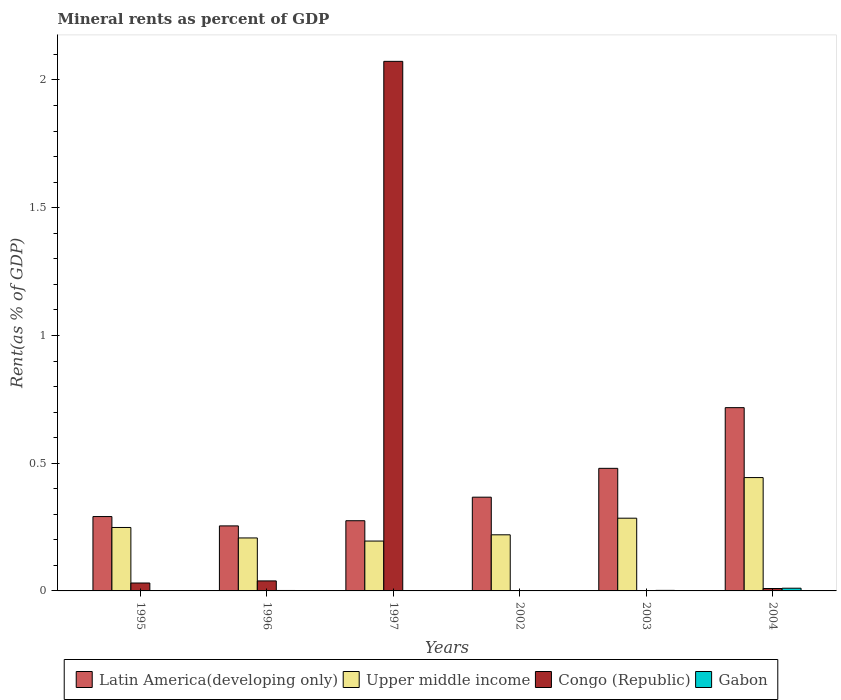How many bars are there on the 6th tick from the left?
Your answer should be very brief. 4. What is the label of the 5th group of bars from the left?
Give a very brief answer. 2003. What is the mineral rent in Congo (Republic) in 2002?
Make the answer very short. 0. Across all years, what is the maximum mineral rent in Latin America(developing only)?
Your response must be concise. 0.72. Across all years, what is the minimum mineral rent in Latin America(developing only)?
Give a very brief answer. 0.25. In which year was the mineral rent in Congo (Republic) maximum?
Your answer should be very brief. 1997. What is the total mineral rent in Congo (Republic) in the graph?
Provide a short and direct response. 2.15. What is the difference between the mineral rent in Gabon in 1995 and that in 1996?
Ensure brevity in your answer.  -0. What is the difference between the mineral rent in Latin America(developing only) in 1996 and the mineral rent in Gabon in 2004?
Offer a terse response. 0.24. What is the average mineral rent in Latin America(developing only) per year?
Provide a succinct answer. 0.4. In the year 1995, what is the difference between the mineral rent in Congo (Republic) and mineral rent in Latin America(developing only)?
Give a very brief answer. -0.26. What is the ratio of the mineral rent in Gabon in 2003 to that in 2004?
Provide a short and direct response. 0.2. Is the mineral rent in Upper middle income in 1997 less than that in 2002?
Provide a succinct answer. Yes. Is the difference between the mineral rent in Congo (Republic) in 1995 and 2004 greater than the difference between the mineral rent in Latin America(developing only) in 1995 and 2004?
Make the answer very short. Yes. What is the difference between the highest and the second highest mineral rent in Congo (Republic)?
Your response must be concise. 2.03. What is the difference between the highest and the lowest mineral rent in Latin America(developing only)?
Ensure brevity in your answer.  0.46. Is the sum of the mineral rent in Upper middle income in 1996 and 2003 greater than the maximum mineral rent in Latin America(developing only) across all years?
Offer a very short reply. No. What does the 4th bar from the left in 2004 represents?
Keep it short and to the point. Gabon. What does the 4th bar from the right in 1995 represents?
Make the answer very short. Latin America(developing only). Are all the bars in the graph horizontal?
Give a very brief answer. No. Are the values on the major ticks of Y-axis written in scientific E-notation?
Offer a terse response. No. Does the graph contain any zero values?
Make the answer very short. No. Does the graph contain grids?
Offer a very short reply. No. Where does the legend appear in the graph?
Give a very brief answer. Bottom center. How many legend labels are there?
Your answer should be very brief. 4. What is the title of the graph?
Offer a terse response. Mineral rents as percent of GDP. Does "Fiji" appear as one of the legend labels in the graph?
Your answer should be very brief. No. What is the label or title of the Y-axis?
Your answer should be very brief. Rent(as % of GDP). What is the Rent(as % of GDP) in Latin America(developing only) in 1995?
Keep it short and to the point. 0.29. What is the Rent(as % of GDP) in Upper middle income in 1995?
Keep it short and to the point. 0.25. What is the Rent(as % of GDP) in Congo (Republic) in 1995?
Give a very brief answer. 0.03. What is the Rent(as % of GDP) of Gabon in 1995?
Give a very brief answer. 0. What is the Rent(as % of GDP) of Latin America(developing only) in 1996?
Provide a short and direct response. 0.25. What is the Rent(as % of GDP) of Upper middle income in 1996?
Your answer should be very brief. 0.21. What is the Rent(as % of GDP) of Congo (Republic) in 1996?
Your response must be concise. 0.04. What is the Rent(as % of GDP) in Gabon in 1996?
Give a very brief answer. 0. What is the Rent(as % of GDP) in Latin America(developing only) in 1997?
Ensure brevity in your answer.  0.27. What is the Rent(as % of GDP) in Upper middle income in 1997?
Your answer should be compact. 0.2. What is the Rent(as % of GDP) of Congo (Republic) in 1997?
Offer a terse response. 2.07. What is the Rent(as % of GDP) in Gabon in 1997?
Ensure brevity in your answer.  0. What is the Rent(as % of GDP) in Latin America(developing only) in 2002?
Offer a terse response. 0.37. What is the Rent(as % of GDP) of Upper middle income in 2002?
Your answer should be compact. 0.22. What is the Rent(as % of GDP) in Congo (Republic) in 2002?
Keep it short and to the point. 0. What is the Rent(as % of GDP) of Gabon in 2002?
Offer a terse response. 0. What is the Rent(as % of GDP) of Latin America(developing only) in 2003?
Your response must be concise. 0.48. What is the Rent(as % of GDP) in Upper middle income in 2003?
Your answer should be compact. 0.28. What is the Rent(as % of GDP) in Congo (Republic) in 2003?
Your response must be concise. 0. What is the Rent(as % of GDP) in Gabon in 2003?
Keep it short and to the point. 0. What is the Rent(as % of GDP) in Latin America(developing only) in 2004?
Your response must be concise. 0.72. What is the Rent(as % of GDP) in Upper middle income in 2004?
Offer a very short reply. 0.44. What is the Rent(as % of GDP) of Congo (Republic) in 2004?
Provide a short and direct response. 0.01. What is the Rent(as % of GDP) of Gabon in 2004?
Your answer should be compact. 0.01. Across all years, what is the maximum Rent(as % of GDP) of Latin America(developing only)?
Provide a short and direct response. 0.72. Across all years, what is the maximum Rent(as % of GDP) of Upper middle income?
Give a very brief answer. 0.44. Across all years, what is the maximum Rent(as % of GDP) of Congo (Republic)?
Your response must be concise. 2.07. Across all years, what is the maximum Rent(as % of GDP) of Gabon?
Make the answer very short. 0.01. Across all years, what is the minimum Rent(as % of GDP) of Latin America(developing only)?
Your answer should be very brief. 0.25. Across all years, what is the minimum Rent(as % of GDP) in Upper middle income?
Provide a succinct answer. 0.2. Across all years, what is the minimum Rent(as % of GDP) of Congo (Republic)?
Your response must be concise. 0. Across all years, what is the minimum Rent(as % of GDP) of Gabon?
Provide a short and direct response. 0. What is the total Rent(as % of GDP) in Latin America(developing only) in the graph?
Your answer should be very brief. 2.38. What is the total Rent(as % of GDP) of Upper middle income in the graph?
Give a very brief answer. 1.6. What is the total Rent(as % of GDP) in Congo (Republic) in the graph?
Keep it short and to the point. 2.15. What is the total Rent(as % of GDP) of Gabon in the graph?
Make the answer very short. 0.02. What is the difference between the Rent(as % of GDP) of Latin America(developing only) in 1995 and that in 1996?
Offer a terse response. 0.04. What is the difference between the Rent(as % of GDP) of Upper middle income in 1995 and that in 1996?
Provide a short and direct response. 0.04. What is the difference between the Rent(as % of GDP) of Congo (Republic) in 1995 and that in 1996?
Give a very brief answer. -0.01. What is the difference between the Rent(as % of GDP) of Gabon in 1995 and that in 1996?
Ensure brevity in your answer.  -0. What is the difference between the Rent(as % of GDP) in Latin America(developing only) in 1995 and that in 1997?
Offer a terse response. 0.02. What is the difference between the Rent(as % of GDP) of Upper middle income in 1995 and that in 1997?
Your answer should be compact. 0.05. What is the difference between the Rent(as % of GDP) of Congo (Republic) in 1995 and that in 1997?
Provide a short and direct response. -2.04. What is the difference between the Rent(as % of GDP) of Gabon in 1995 and that in 1997?
Provide a short and direct response. 0. What is the difference between the Rent(as % of GDP) of Latin America(developing only) in 1995 and that in 2002?
Ensure brevity in your answer.  -0.08. What is the difference between the Rent(as % of GDP) of Upper middle income in 1995 and that in 2002?
Your answer should be very brief. 0.03. What is the difference between the Rent(as % of GDP) in Congo (Republic) in 1995 and that in 2002?
Give a very brief answer. 0.03. What is the difference between the Rent(as % of GDP) in Gabon in 1995 and that in 2002?
Provide a short and direct response. 0. What is the difference between the Rent(as % of GDP) in Latin America(developing only) in 1995 and that in 2003?
Provide a short and direct response. -0.19. What is the difference between the Rent(as % of GDP) in Upper middle income in 1995 and that in 2003?
Provide a short and direct response. -0.04. What is the difference between the Rent(as % of GDP) in Congo (Republic) in 1995 and that in 2003?
Your response must be concise. 0.03. What is the difference between the Rent(as % of GDP) of Gabon in 1995 and that in 2003?
Offer a terse response. -0. What is the difference between the Rent(as % of GDP) in Latin America(developing only) in 1995 and that in 2004?
Offer a terse response. -0.43. What is the difference between the Rent(as % of GDP) of Upper middle income in 1995 and that in 2004?
Give a very brief answer. -0.2. What is the difference between the Rent(as % of GDP) in Congo (Republic) in 1995 and that in 2004?
Your answer should be very brief. 0.02. What is the difference between the Rent(as % of GDP) of Gabon in 1995 and that in 2004?
Provide a short and direct response. -0.01. What is the difference between the Rent(as % of GDP) in Latin America(developing only) in 1996 and that in 1997?
Provide a short and direct response. -0.02. What is the difference between the Rent(as % of GDP) of Upper middle income in 1996 and that in 1997?
Give a very brief answer. 0.01. What is the difference between the Rent(as % of GDP) in Congo (Republic) in 1996 and that in 1997?
Your answer should be compact. -2.03. What is the difference between the Rent(as % of GDP) of Gabon in 1996 and that in 1997?
Your response must be concise. 0. What is the difference between the Rent(as % of GDP) of Latin America(developing only) in 1996 and that in 2002?
Keep it short and to the point. -0.11. What is the difference between the Rent(as % of GDP) of Upper middle income in 1996 and that in 2002?
Offer a terse response. -0.01. What is the difference between the Rent(as % of GDP) in Congo (Republic) in 1996 and that in 2002?
Offer a terse response. 0.04. What is the difference between the Rent(as % of GDP) in Gabon in 1996 and that in 2002?
Provide a succinct answer. 0. What is the difference between the Rent(as % of GDP) of Latin America(developing only) in 1996 and that in 2003?
Make the answer very short. -0.23. What is the difference between the Rent(as % of GDP) in Upper middle income in 1996 and that in 2003?
Make the answer very short. -0.08. What is the difference between the Rent(as % of GDP) of Congo (Republic) in 1996 and that in 2003?
Make the answer very short. 0.04. What is the difference between the Rent(as % of GDP) of Gabon in 1996 and that in 2003?
Offer a terse response. -0. What is the difference between the Rent(as % of GDP) of Latin America(developing only) in 1996 and that in 2004?
Your answer should be very brief. -0.46. What is the difference between the Rent(as % of GDP) of Upper middle income in 1996 and that in 2004?
Offer a terse response. -0.24. What is the difference between the Rent(as % of GDP) of Congo (Republic) in 1996 and that in 2004?
Your answer should be compact. 0.03. What is the difference between the Rent(as % of GDP) of Gabon in 1996 and that in 2004?
Give a very brief answer. -0.01. What is the difference between the Rent(as % of GDP) in Latin America(developing only) in 1997 and that in 2002?
Ensure brevity in your answer.  -0.09. What is the difference between the Rent(as % of GDP) of Upper middle income in 1997 and that in 2002?
Your response must be concise. -0.02. What is the difference between the Rent(as % of GDP) of Congo (Republic) in 1997 and that in 2002?
Offer a terse response. 2.07. What is the difference between the Rent(as % of GDP) in Gabon in 1997 and that in 2002?
Keep it short and to the point. -0. What is the difference between the Rent(as % of GDP) in Latin America(developing only) in 1997 and that in 2003?
Your answer should be compact. -0.2. What is the difference between the Rent(as % of GDP) in Upper middle income in 1997 and that in 2003?
Offer a terse response. -0.09. What is the difference between the Rent(as % of GDP) in Congo (Republic) in 1997 and that in 2003?
Your response must be concise. 2.07. What is the difference between the Rent(as % of GDP) in Gabon in 1997 and that in 2003?
Give a very brief answer. -0. What is the difference between the Rent(as % of GDP) in Latin America(developing only) in 1997 and that in 2004?
Provide a short and direct response. -0.44. What is the difference between the Rent(as % of GDP) of Upper middle income in 1997 and that in 2004?
Keep it short and to the point. -0.25. What is the difference between the Rent(as % of GDP) in Congo (Republic) in 1997 and that in 2004?
Provide a succinct answer. 2.06. What is the difference between the Rent(as % of GDP) in Gabon in 1997 and that in 2004?
Offer a very short reply. -0.01. What is the difference between the Rent(as % of GDP) of Latin America(developing only) in 2002 and that in 2003?
Your response must be concise. -0.11. What is the difference between the Rent(as % of GDP) of Upper middle income in 2002 and that in 2003?
Your answer should be very brief. -0.07. What is the difference between the Rent(as % of GDP) in Congo (Republic) in 2002 and that in 2003?
Offer a very short reply. -0. What is the difference between the Rent(as % of GDP) of Gabon in 2002 and that in 2003?
Give a very brief answer. -0. What is the difference between the Rent(as % of GDP) in Latin America(developing only) in 2002 and that in 2004?
Your response must be concise. -0.35. What is the difference between the Rent(as % of GDP) of Upper middle income in 2002 and that in 2004?
Your response must be concise. -0.22. What is the difference between the Rent(as % of GDP) in Congo (Republic) in 2002 and that in 2004?
Keep it short and to the point. -0.01. What is the difference between the Rent(as % of GDP) in Gabon in 2002 and that in 2004?
Give a very brief answer. -0.01. What is the difference between the Rent(as % of GDP) in Latin America(developing only) in 2003 and that in 2004?
Provide a succinct answer. -0.24. What is the difference between the Rent(as % of GDP) of Upper middle income in 2003 and that in 2004?
Offer a terse response. -0.16. What is the difference between the Rent(as % of GDP) of Congo (Republic) in 2003 and that in 2004?
Give a very brief answer. -0.01. What is the difference between the Rent(as % of GDP) in Gabon in 2003 and that in 2004?
Offer a terse response. -0.01. What is the difference between the Rent(as % of GDP) of Latin America(developing only) in 1995 and the Rent(as % of GDP) of Upper middle income in 1996?
Provide a short and direct response. 0.08. What is the difference between the Rent(as % of GDP) of Latin America(developing only) in 1995 and the Rent(as % of GDP) of Congo (Republic) in 1996?
Make the answer very short. 0.25. What is the difference between the Rent(as % of GDP) of Latin America(developing only) in 1995 and the Rent(as % of GDP) of Gabon in 1996?
Provide a short and direct response. 0.29. What is the difference between the Rent(as % of GDP) of Upper middle income in 1995 and the Rent(as % of GDP) of Congo (Republic) in 1996?
Ensure brevity in your answer.  0.21. What is the difference between the Rent(as % of GDP) in Upper middle income in 1995 and the Rent(as % of GDP) in Gabon in 1996?
Keep it short and to the point. 0.25. What is the difference between the Rent(as % of GDP) of Congo (Republic) in 1995 and the Rent(as % of GDP) of Gabon in 1996?
Keep it short and to the point. 0.03. What is the difference between the Rent(as % of GDP) in Latin America(developing only) in 1995 and the Rent(as % of GDP) in Upper middle income in 1997?
Provide a short and direct response. 0.1. What is the difference between the Rent(as % of GDP) in Latin America(developing only) in 1995 and the Rent(as % of GDP) in Congo (Republic) in 1997?
Your answer should be compact. -1.78. What is the difference between the Rent(as % of GDP) of Latin America(developing only) in 1995 and the Rent(as % of GDP) of Gabon in 1997?
Offer a terse response. 0.29. What is the difference between the Rent(as % of GDP) in Upper middle income in 1995 and the Rent(as % of GDP) in Congo (Republic) in 1997?
Your answer should be very brief. -1.82. What is the difference between the Rent(as % of GDP) in Upper middle income in 1995 and the Rent(as % of GDP) in Gabon in 1997?
Your answer should be very brief. 0.25. What is the difference between the Rent(as % of GDP) in Congo (Republic) in 1995 and the Rent(as % of GDP) in Gabon in 1997?
Offer a very short reply. 0.03. What is the difference between the Rent(as % of GDP) in Latin America(developing only) in 1995 and the Rent(as % of GDP) in Upper middle income in 2002?
Your response must be concise. 0.07. What is the difference between the Rent(as % of GDP) of Latin America(developing only) in 1995 and the Rent(as % of GDP) of Congo (Republic) in 2002?
Ensure brevity in your answer.  0.29. What is the difference between the Rent(as % of GDP) in Latin America(developing only) in 1995 and the Rent(as % of GDP) in Gabon in 2002?
Your answer should be very brief. 0.29. What is the difference between the Rent(as % of GDP) in Upper middle income in 1995 and the Rent(as % of GDP) in Congo (Republic) in 2002?
Ensure brevity in your answer.  0.25. What is the difference between the Rent(as % of GDP) of Upper middle income in 1995 and the Rent(as % of GDP) of Gabon in 2002?
Your response must be concise. 0.25. What is the difference between the Rent(as % of GDP) of Congo (Republic) in 1995 and the Rent(as % of GDP) of Gabon in 2002?
Make the answer very short. 0.03. What is the difference between the Rent(as % of GDP) in Latin America(developing only) in 1995 and the Rent(as % of GDP) in Upper middle income in 2003?
Provide a short and direct response. 0.01. What is the difference between the Rent(as % of GDP) in Latin America(developing only) in 1995 and the Rent(as % of GDP) in Congo (Republic) in 2003?
Offer a terse response. 0.29. What is the difference between the Rent(as % of GDP) of Latin America(developing only) in 1995 and the Rent(as % of GDP) of Gabon in 2003?
Offer a very short reply. 0.29. What is the difference between the Rent(as % of GDP) in Upper middle income in 1995 and the Rent(as % of GDP) in Congo (Republic) in 2003?
Offer a very short reply. 0.25. What is the difference between the Rent(as % of GDP) in Upper middle income in 1995 and the Rent(as % of GDP) in Gabon in 2003?
Give a very brief answer. 0.25. What is the difference between the Rent(as % of GDP) of Congo (Republic) in 1995 and the Rent(as % of GDP) of Gabon in 2003?
Provide a short and direct response. 0.03. What is the difference between the Rent(as % of GDP) in Latin America(developing only) in 1995 and the Rent(as % of GDP) in Upper middle income in 2004?
Your response must be concise. -0.15. What is the difference between the Rent(as % of GDP) in Latin America(developing only) in 1995 and the Rent(as % of GDP) in Congo (Republic) in 2004?
Your answer should be very brief. 0.28. What is the difference between the Rent(as % of GDP) in Latin America(developing only) in 1995 and the Rent(as % of GDP) in Gabon in 2004?
Provide a short and direct response. 0.28. What is the difference between the Rent(as % of GDP) of Upper middle income in 1995 and the Rent(as % of GDP) of Congo (Republic) in 2004?
Provide a short and direct response. 0.24. What is the difference between the Rent(as % of GDP) of Upper middle income in 1995 and the Rent(as % of GDP) of Gabon in 2004?
Offer a very short reply. 0.24. What is the difference between the Rent(as % of GDP) of Congo (Republic) in 1995 and the Rent(as % of GDP) of Gabon in 2004?
Your response must be concise. 0.02. What is the difference between the Rent(as % of GDP) of Latin America(developing only) in 1996 and the Rent(as % of GDP) of Upper middle income in 1997?
Offer a very short reply. 0.06. What is the difference between the Rent(as % of GDP) of Latin America(developing only) in 1996 and the Rent(as % of GDP) of Congo (Republic) in 1997?
Ensure brevity in your answer.  -1.82. What is the difference between the Rent(as % of GDP) in Latin America(developing only) in 1996 and the Rent(as % of GDP) in Gabon in 1997?
Provide a succinct answer. 0.25. What is the difference between the Rent(as % of GDP) in Upper middle income in 1996 and the Rent(as % of GDP) in Congo (Republic) in 1997?
Ensure brevity in your answer.  -1.87. What is the difference between the Rent(as % of GDP) of Upper middle income in 1996 and the Rent(as % of GDP) of Gabon in 1997?
Your answer should be compact. 0.21. What is the difference between the Rent(as % of GDP) of Congo (Republic) in 1996 and the Rent(as % of GDP) of Gabon in 1997?
Your answer should be compact. 0.04. What is the difference between the Rent(as % of GDP) of Latin America(developing only) in 1996 and the Rent(as % of GDP) of Upper middle income in 2002?
Provide a succinct answer. 0.03. What is the difference between the Rent(as % of GDP) in Latin America(developing only) in 1996 and the Rent(as % of GDP) in Congo (Republic) in 2002?
Provide a succinct answer. 0.25. What is the difference between the Rent(as % of GDP) of Latin America(developing only) in 1996 and the Rent(as % of GDP) of Gabon in 2002?
Offer a terse response. 0.25. What is the difference between the Rent(as % of GDP) of Upper middle income in 1996 and the Rent(as % of GDP) of Congo (Republic) in 2002?
Offer a terse response. 0.21. What is the difference between the Rent(as % of GDP) in Upper middle income in 1996 and the Rent(as % of GDP) in Gabon in 2002?
Offer a terse response. 0.21. What is the difference between the Rent(as % of GDP) of Congo (Republic) in 1996 and the Rent(as % of GDP) of Gabon in 2002?
Provide a succinct answer. 0.04. What is the difference between the Rent(as % of GDP) of Latin America(developing only) in 1996 and the Rent(as % of GDP) of Upper middle income in 2003?
Give a very brief answer. -0.03. What is the difference between the Rent(as % of GDP) of Latin America(developing only) in 1996 and the Rent(as % of GDP) of Congo (Republic) in 2003?
Give a very brief answer. 0.25. What is the difference between the Rent(as % of GDP) of Latin America(developing only) in 1996 and the Rent(as % of GDP) of Gabon in 2003?
Ensure brevity in your answer.  0.25. What is the difference between the Rent(as % of GDP) of Upper middle income in 1996 and the Rent(as % of GDP) of Congo (Republic) in 2003?
Ensure brevity in your answer.  0.21. What is the difference between the Rent(as % of GDP) of Upper middle income in 1996 and the Rent(as % of GDP) of Gabon in 2003?
Provide a short and direct response. 0.21. What is the difference between the Rent(as % of GDP) in Congo (Republic) in 1996 and the Rent(as % of GDP) in Gabon in 2003?
Your answer should be compact. 0.04. What is the difference between the Rent(as % of GDP) of Latin America(developing only) in 1996 and the Rent(as % of GDP) of Upper middle income in 2004?
Offer a very short reply. -0.19. What is the difference between the Rent(as % of GDP) of Latin America(developing only) in 1996 and the Rent(as % of GDP) of Congo (Republic) in 2004?
Your answer should be very brief. 0.25. What is the difference between the Rent(as % of GDP) in Latin America(developing only) in 1996 and the Rent(as % of GDP) in Gabon in 2004?
Ensure brevity in your answer.  0.24. What is the difference between the Rent(as % of GDP) in Upper middle income in 1996 and the Rent(as % of GDP) in Congo (Republic) in 2004?
Offer a terse response. 0.2. What is the difference between the Rent(as % of GDP) of Upper middle income in 1996 and the Rent(as % of GDP) of Gabon in 2004?
Your response must be concise. 0.2. What is the difference between the Rent(as % of GDP) of Congo (Republic) in 1996 and the Rent(as % of GDP) of Gabon in 2004?
Offer a terse response. 0.03. What is the difference between the Rent(as % of GDP) in Latin America(developing only) in 1997 and the Rent(as % of GDP) in Upper middle income in 2002?
Provide a short and direct response. 0.06. What is the difference between the Rent(as % of GDP) of Latin America(developing only) in 1997 and the Rent(as % of GDP) of Congo (Republic) in 2002?
Make the answer very short. 0.27. What is the difference between the Rent(as % of GDP) in Latin America(developing only) in 1997 and the Rent(as % of GDP) in Gabon in 2002?
Offer a very short reply. 0.27. What is the difference between the Rent(as % of GDP) in Upper middle income in 1997 and the Rent(as % of GDP) in Congo (Republic) in 2002?
Make the answer very short. 0.2. What is the difference between the Rent(as % of GDP) of Upper middle income in 1997 and the Rent(as % of GDP) of Gabon in 2002?
Offer a very short reply. 0.19. What is the difference between the Rent(as % of GDP) of Congo (Republic) in 1997 and the Rent(as % of GDP) of Gabon in 2002?
Offer a very short reply. 2.07. What is the difference between the Rent(as % of GDP) of Latin America(developing only) in 1997 and the Rent(as % of GDP) of Upper middle income in 2003?
Keep it short and to the point. -0.01. What is the difference between the Rent(as % of GDP) in Latin America(developing only) in 1997 and the Rent(as % of GDP) in Congo (Republic) in 2003?
Offer a very short reply. 0.27. What is the difference between the Rent(as % of GDP) in Latin America(developing only) in 1997 and the Rent(as % of GDP) in Gabon in 2003?
Offer a terse response. 0.27. What is the difference between the Rent(as % of GDP) in Upper middle income in 1997 and the Rent(as % of GDP) in Congo (Republic) in 2003?
Provide a short and direct response. 0.19. What is the difference between the Rent(as % of GDP) of Upper middle income in 1997 and the Rent(as % of GDP) of Gabon in 2003?
Provide a short and direct response. 0.19. What is the difference between the Rent(as % of GDP) in Congo (Republic) in 1997 and the Rent(as % of GDP) in Gabon in 2003?
Provide a short and direct response. 2.07. What is the difference between the Rent(as % of GDP) of Latin America(developing only) in 1997 and the Rent(as % of GDP) of Upper middle income in 2004?
Your response must be concise. -0.17. What is the difference between the Rent(as % of GDP) of Latin America(developing only) in 1997 and the Rent(as % of GDP) of Congo (Republic) in 2004?
Your response must be concise. 0.27. What is the difference between the Rent(as % of GDP) of Latin America(developing only) in 1997 and the Rent(as % of GDP) of Gabon in 2004?
Your answer should be compact. 0.26. What is the difference between the Rent(as % of GDP) of Upper middle income in 1997 and the Rent(as % of GDP) of Congo (Republic) in 2004?
Provide a succinct answer. 0.19. What is the difference between the Rent(as % of GDP) of Upper middle income in 1997 and the Rent(as % of GDP) of Gabon in 2004?
Ensure brevity in your answer.  0.18. What is the difference between the Rent(as % of GDP) of Congo (Republic) in 1997 and the Rent(as % of GDP) of Gabon in 2004?
Provide a short and direct response. 2.06. What is the difference between the Rent(as % of GDP) of Latin America(developing only) in 2002 and the Rent(as % of GDP) of Upper middle income in 2003?
Provide a succinct answer. 0.08. What is the difference between the Rent(as % of GDP) in Latin America(developing only) in 2002 and the Rent(as % of GDP) in Congo (Republic) in 2003?
Offer a very short reply. 0.37. What is the difference between the Rent(as % of GDP) in Latin America(developing only) in 2002 and the Rent(as % of GDP) in Gabon in 2003?
Your answer should be very brief. 0.36. What is the difference between the Rent(as % of GDP) in Upper middle income in 2002 and the Rent(as % of GDP) in Congo (Republic) in 2003?
Give a very brief answer. 0.22. What is the difference between the Rent(as % of GDP) in Upper middle income in 2002 and the Rent(as % of GDP) in Gabon in 2003?
Your answer should be compact. 0.22. What is the difference between the Rent(as % of GDP) in Congo (Republic) in 2002 and the Rent(as % of GDP) in Gabon in 2003?
Your answer should be very brief. -0. What is the difference between the Rent(as % of GDP) of Latin America(developing only) in 2002 and the Rent(as % of GDP) of Upper middle income in 2004?
Ensure brevity in your answer.  -0.08. What is the difference between the Rent(as % of GDP) in Latin America(developing only) in 2002 and the Rent(as % of GDP) in Congo (Republic) in 2004?
Offer a terse response. 0.36. What is the difference between the Rent(as % of GDP) in Latin America(developing only) in 2002 and the Rent(as % of GDP) in Gabon in 2004?
Make the answer very short. 0.36. What is the difference between the Rent(as % of GDP) of Upper middle income in 2002 and the Rent(as % of GDP) of Congo (Republic) in 2004?
Give a very brief answer. 0.21. What is the difference between the Rent(as % of GDP) of Upper middle income in 2002 and the Rent(as % of GDP) of Gabon in 2004?
Provide a short and direct response. 0.21. What is the difference between the Rent(as % of GDP) of Congo (Republic) in 2002 and the Rent(as % of GDP) of Gabon in 2004?
Give a very brief answer. -0.01. What is the difference between the Rent(as % of GDP) in Latin America(developing only) in 2003 and the Rent(as % of GDP) in Upper middle income in 2004?
Offer a terse response. 0.04. What is the difference between the Rent(as % of GDP) in Latin America(developing only) in 2003 and the Rent(as % of GDP) in Congo (Republic) in 2004?
Offer a terse response. 0.47. What is the difference between the Rent(as % of GDP) of Latin America(developing only) in 2003 and the Rent(as % of GDP) of Gabon in 2004?
Your answer should be very brief. 0.47. What is the difference between the Rent(as % of GDP) in Upper middle income in 2003 and the Rent(as % of GDP) in Congo (Republic) in 2004?
Your response must be concise. 0.28. What is the difference between the Rent(as % of GDP) in Upper middle income in 2003 and the Rent(as % of GDP) in Gabon in 2004?
Give a very brief answer. 0.27. What is the difference between the Rent(as % of GDP) of Congo (Republic) in 2003 and the Rent(as % of GDP) of Gabon in 2004?
Your response must be concise. -0.01. What is the average Rent(as % of GDP) in Latin America(developing only) per year?
Offer a terse response. 0.4. What is the average Rent(as % of GDP) in Upper middle income per year?
Your response must be concise. 0.27. What is the average Rent(as % of GDP) in Congo (Republic) per year?
Your response must be concise. 0.36. What is the average Rent(as % of GDP) of Gabon per year?
Your response must be concise. 0. In the year 1995, what is the difference between the Rent(as % of GDP) in Latin America(developing only) and Rent(as % of GDP) in Upper middle income?
Your answer should be very brief. 0.04. In the year 1995, what is the difference between the Rent(as % of GDP) in Latin America(developing only) and Rent(as % of GDP) in Congo (Republic)?
Provide a succinct answer. 0.26. In the year 1995, what is the difference between the Rent(as % of GDP) in Latin America(developing only) and Rent(as % of GDP) in Gabon?
Ensure brevity in your answer.  0.29. In the year 1995, what is the difference between the Rent(as % of GDP) of Upper middle income and Rent(as % of GDP) of Congo (Republic)?
Ensure brevity in your answer.  0.22. In the year 1995, what is the difference between the Rent(as % of GDP) of Upper middle income and Rent(as % of GDP) of Gabon?
Provide a short and direct response. 0.25. In the year 1995, what is the difference between the Rent(as % of GDP) in Congo (Republic) and Rent(as % of GDP) in Gabon?
Provide a short and direct response. 0.03. In the year 1996, what is the difference between the Rent(as % of GDP) of Latin America(developing only) and Rent(as % of GDP) of Upper middle income?
Provide a short and direct response. 0.05. In the year 1996, what is the difference between the Rent(as % of GDP) in Latin America(developing only) and Rent(as % of GDP) in Congo (Republic)?
Your answer should be compact. 0.22. In the year 1996, what is the difference between the Rent(as % of GDP) of Latin America(developing only) and Rent(as % of GDP) of Gabon?
Provide a short and direct response. 0.25. In the year 1996, what is the difference between the Rent(as % of GDP) of Upper middle income and Rent(as % of GDP) of Congo (Republic)?
Your response must be concise. 0.17. In the year 1996, what is the difference between the Rent(as % of GDP) in Upper middle income and Rent(as % of GDP) in Gabon?
Offer a very short reply. 0.21. In the year 1996, what is the difference between the Rent(as % of GDP) in Congo (Republic) and Rent(as % of GDP) in Gabon?
Your answer should be compact. 0.04. In the year 1997, what is the difference between the Rent(as % of GDP) in Latin America(developing only) and Rent(as % of GDP) in Upper middle income?
Your response must be concise. 0.08. In the year 1997, what is the difference between the Rent(as % of GDP) in Latin America(developing only) and Rent(as % of GDP) in Congo (Republic)?
Provide a short and direct response. -1.8. In the year 1997, what is the difference between the Rent(as % of GDP) in Latin America(developing only) and Rent(as % of GDP) in Gabon?
Give a very brief answer. 0.27. In the year 1997, what is the difference between the Rent(as % of GDP) of Upper middle income and Rent(as % of GDP) of Congo (Republic)?
Provide a short and direct response. -1.88. In the year 1997, what is the difference between the Rent(as % of GDP) in Upper middle income and Rent(as % of GDP) in Gabon?
Provide a short and direct response. 0.2. In the year 1997, what is the difference between the Rent(as % of GDP) in Congo (Republic) and Rent(as % of GDP) in Gabon?
Offer a very short reply. 2.07. In the year 2002, what is the difference between the Rent(as % of GDP) in Latin America(developing only) and Rent(as % of GDP) in Upper middle income?
Provide a succinct answer. 0.15. In the year 2002, what is the difference between the Rent(as % of GDP) in Latin America(developing only) and Rent(as % of GDP) in Congo (Republic)?
Provide a short and direct response. 0.37. In the year 2002, what is the difference between the Rent(as % of GDP) of Latin America(developing only) and Rent(as % of GDP) of Gabon?
Ensure brevity in your answer.  0.37. In the year 2002, what is the difference between the Rent(as % of GDP) in Upper middle income and Rent(as % of GDP) in Congo (Republic)?
Make the answer very short. 0.22. In the year 2002, what is the difference between the Rent(as % of GDP) in Upper middle income and Rent(as % of GDP) in Gabon?
Ensure brevity in your answer.  0.22. In the year 2002, what is the difference between the Rent(as % of GDP) in Congo (Republic) and Rent(as % of GDP) in Gabon?
Make the answer very short. -0. In the year 2003, what is the difference between the Rent(as % of GDP) in Latin America(developing only) and Rent(as % of GDP) in Upper middle income?
Your answer should be very brief. 0.2. In the year 2003, what is the difference between the Rent(as % of GDP) in Latin America(developing only) and Rent(as % of GDP) in Congo (Republic)?
Your response must be concise. 0.48. In the year 2003, what is the difference between the Rent(as % of GDP) in Latin America(developing only) and Rent(as % of GDP) in Gabon?
Your answer should be very brief. 0.48. In the year 2003, what is the difference between the Rent(as % of GDP) in Upper middle income and Rent(as % of GDP) in Congo (Republic)?
Offer a very short reply. 0.28. In the year 2003, what is the difference between the Rent(as % of GDP) in Upper middle income and Rent(as % of GDP) in Gabon?
Ensure brevity in your answer.  0.28. In the year 2003, what is the difference between the Rent(as % of GDP) of Congo (Republic) and Rent(as % of GDP) of Gabon?
Your answer should be very brief. -0. In the year 2004, what is the difference between the Rent(as % of GDP) of Latin America(developing only) and Rent(as % of GDP) of Upper middle income?
Your answer should be very brief. 0.27. In the year 2004, what is the difference between the Rent(as % of GDP) of Latin America(developing only) and Rent(as % of GDP) of Congo (Republic)?
Offer a terse response. 0.71. In the year 2004, what is the difference between the Rent(as % of GDP) in Latin America(developing only) and Rent(as % of GDP) in Gabon?
Provide a succinct answer. 0.71. In the year 2004, what is the difference between the Rent(as % of GDP) of Upper middle income and Rent(as % of GDP) of Congo (Republic)?
Offer a very short reply. 0.43. In the year 2004, what is the difference between the Rent(as % of GDP) of Upper middle income and Rent(as % of GDP) of Gabon?
Keep it short and to the point. 0.43. In the year 2004, what is the difference between the Rent(as % of GDP) of Congo (Republic) and Rent(as % of GDP) of Gabon?
Offer a terse response. -0. What is the ratio of the Rent(as % of GDP) of Latin America(developing only) in 1995 to that in 1996?
Provide a succinct answer. 1.14. What is the ratio of the Rent(as % of GDP) in Upper middle income in 1995 to that in 1996?
Offer a terse response. 1.2. What is the ratio of the Rent(as % of GDP) of Congo (Republic) in 1995 to that in 1996?
Keep it short and to the point. 0.79. What is the ratio of the Rent(as % of GDP) in Gabon in 1995 to that in 1996?
Keep it short and to the point. 0.88. What is the ratio of the Rent(as % of GDP) in Latin America(developing only) in 1995 to that in 1997?
Make the answer very short. 1.06. What is the ratio of the Rent(as % of GDP) of Upper middle income in 1995 to that in 1997?
Your answer should be very brief. 1.27. What is the ratio of the Rent(as % of GDP) in Congo (Republic) in 1995 to that in 1997?
Offer a very short reply. 0.01. What is the ratio of the Rent(as % of GDP) of Gabon in 1995 to that in 1997?
Offer a terse response. 9.67. What is the ratio of the Rent(as % of GDP) in Latin America(developing only) in 1995 to that in 2002?
Your answer should be compact. 0.79. What is the ratio of the Rent(as % of GDP) of Upper middle income in 1995 to that in 2002?
Offer a terse response. 1.13. What is the ratio of the Rent(as % of GDP) in Congo (Republic) in 1995 to that in 2002?
Provide a short and direct response. 134.41. What is the ratio of the Rent(as % of GDP) in Gabon in 1995 to that in 2002?
Offer a terse response. 1.68. What is the ratio of the Rent(as % of GDP) of Latin America(developing only) in 1995 to that in 2003?
Offer a very short reply. 0.61. What is the ratio of the Rent(as % of GDP) of Upper middle income in 1995 to that in 2003?
Offer a terse response. 0.87. What is the ratio of the Rent(as % of GDP) of Congo (Republic) in 1995 to that in 2003?
Give a very brief answer. 55.97. What is the ratio of the Rent(as % of GDP) of Gabon in 1995 to that in 2003?
Keep it short and to the point. 0.74. What is the ratio of the Rent(as % of GDP) in Latin America(developing only) in 1995 to that in 2004?
Your response must be concise. 0.41. What is the ratio of the Rent(as % of GDP) in Upper middle income in 1995 to that in 2004?
Your answer should be very brief. 0.56. What is the ratio of the Rent(as % of GDP) in Congo (Republic) in 1995 to that in 2004?
Give a very brief answer. 3.28. What is the ratio of the Rent(as % of GDP) of Gabon in 1995 to that in 2004?
Your answer should be very brief. 0.15. What is the ratio of the Rent(as % of GDP) in Latin America(developing only) in 1996 to that in 1997?
Offer a terse response. 0.93. What is the ratio of the Rent(as % of GDP) in Upper middle income in 1996 to that in 1997?
Make the answer very short. 1.06. What is the ratio of the Rent(as % of GDP) in Congo (Republic) in 1996 to that in 1997?
Offer a very short reply. 0.02. What is the ratio of the Rent(as % of GDP) in Gabon in 1996 to that in 1997?
Provide a short and direct response. 10.95. What is the ratio of the Rent(as % of GDP) of Latin America(developing only) in 1996 to that in 2002?
Your answer should be very brief. 0.69. What is the ratio of the Rent(as % of GDP) of Upper middle income in 1996 to that in 2002?
Make the answer very short. 0.94. What is the ratio of the Rent(as % of GDP) in Congo (Republic) in 1996 to that in 2002?
Your answer should be compact. 169.8. What is the ratio of the Rent(as % of GDP) in Gabon in 1996 to that in 2002?
Provide a succinct answer. 1.9. What is the ratio of the Rent(as % of GDP) in Latin America(developing only) in 1996 to that in 2003?
Your response must be concise. 0.53. What is the ratio of the Rent(as % of GDP) in Upper middle income in 1996 to that in 2003?
Give a very brief answer. 0.73. What is the ratio of the Rent(as % of GDP) in Congo (Republic) in 1996 to that in 2003?
Your answer should be compact. 70.71. What is the ratio of the Rent(as % of GDP) of Gabon in 1996 to that in 2003?
Provide a short and direct response. 0.84. What is the ratio of the Rent(as % of GDP) of Latin America(developing only) in 1996 to that in 2004?
Your response must be concise. 0.35. What is the ratio of the Rent(as % of GDP) in Upper middle income in 1996 to that in 2004?
Make the answer very short. 0.47. What is the ratio of the Rent(as % of GDP) of Congo (Republic) in 1996 to that in 2004?
Offer a terse response. 4.15. What is the ratio of the Rent(as % of GDP) of Gabon in 1996 to that in 2004?
Provide a succinct answer. 0.16. What is the ratio of the Rent(as % of GDP) of Latin America(developing only) in 1997 to that in 2002?
Your answer should be very brief. 0.75. What is the ratio of the Rent(as % of GDP) of Upper middle income in 1997 to that in 2002?
Your response must be concise. 0.89. What is the ratio of the Rent(as % of GDP) in Congo (Republic) in 1997 to that in 2002?
Offer a terse response. 8990.23. What is the ratio of the Rent(as % of GDP) in Gabon in 1997 to that in 2002?
Your answer should be very brief. 0.17. What is the ratio of the Rent(as % of GDP) in Latin America(developing only) in 1997 to that in 2003?
Give a very brief answer. 0.57. What is the ratio of the Rent(as % of GDP) of Upper middle income in 1997 to that in 2003?
Offer a very short reply. 0.69. What is the ratio of the Rent(as % of GDP) of Congo (Republic) in 1997 to that in 2003?
Make the answer very short. 3743.86. What is the ratio of the Rent(as % of GDP) in Gabon in 1997 to that in 2003?
Keep it short and to the point. 0.08. What is the ratio of the Rent(as % of GDP) in Latin America(developing only) in 1997 to that in 2004?
Make the answer very short. 0.38. What is the ratio of the Rent(as % of GDP) in Upper middle income in 1997 to that in 2004?
Provide a succinct answer. 0.44. What is the ratio of the Rent(as % of GDP) of Congo (Republic) in 1997 to that in 2004?
Your answer should be compact. 219.6. What is the ratio of the Rent(as % of GDP) of Gabon in 1997 to that in 2004?
Ensure brevity in your answer.  0.01. What is the ratio of the Rent(as % of GDP) in Latin America(developing only) in 2002 to that in 2003?
Provide a succinct answer. 0.76. What is the ratio of the Rent(as % of GDP) of Upper middle income in 2002 to that in 2003?
Give a very brief answer. 0.77. What is the ratio of the Rent(as % of GDP) of Congo (Republic) in 2002 to that in 2003?
Give a very brief answer. 0.42. What is the ratio of the Rent(as % of GDP) of Gabon in 2002 to that in 2003?
Your answer should be very brief. 0.44. What is the ratio of the Rent(as % of GDP) in Latin America(developing only) in 2002 to that in 2004?
Your answer should be compact. 0.51. What is the ratio of the Rent(as % of GDP) in Upper middle income in 2002 to that in 2004?
Offer a very short reply. 0.49. What is the ratio of the Rent(as % of GDP) in Congo (Republic) in 2002 to that in 2004?
Your answer should be very brief. 0.02. What is the ratio of the Rent(as % of GDP) of Gabon in 2002 to that in 2004?
Provide a succinct answer. 0.09. What is the ratio of the Rent(as % of GDP) of Latin America(developing only) in 2003 to that in 2004?
Your answer should be very brief. 0.67. What is the ratio of the Rent(as % of GDP) in Upper middle income in 2003 to that in 2004?
Provide a succinct answer. 0.64. What is the ratio of the Rent(as % of GDP) of Congo (Republic) in 2003 to that in 2004?
Make the answer very short. 0.06. What is the ratio of the Rent(as % of GDP) of Gabon in 2003 to that in 2004?
Provide a short and direct response. 0.2. What is the difference between the highest and the second highest Rent(as % of GDP) of Latin America(developing only)?
Make the answer very short. 0.24. What is the difference between the highest and the second highest Rent(as % of GDP) of Upper middle income?
Provide a short and direct response. 0.16. What is the difference between the highest and the second highest Rent(as % of GDP) in Congo (Republic)?
Ensure brevity in your answer.  2.03. What is the difference between the highest and the second highest Rent(as % of GDP) in Gabon?
Provide a short and direct response. 0.01. What is the difference between the highest and the lowest Rent(as % of GDP) in Latin America(developing only)?
Offer a terse response. 0.46. What is the difference between the highest and the lowest Rent(as % of GDP) in Upper middle income?
Give a very brief answer. 0.25. What is the difference between the highest and the lowest Rent(as % of GDP) of Congo (Republic)?
Offer a terse response. 2.07. What is the difference between the highest and the lowest Rent(as % of GDP) of Gabon?
Ensure brevity in your answer.  0.01. 